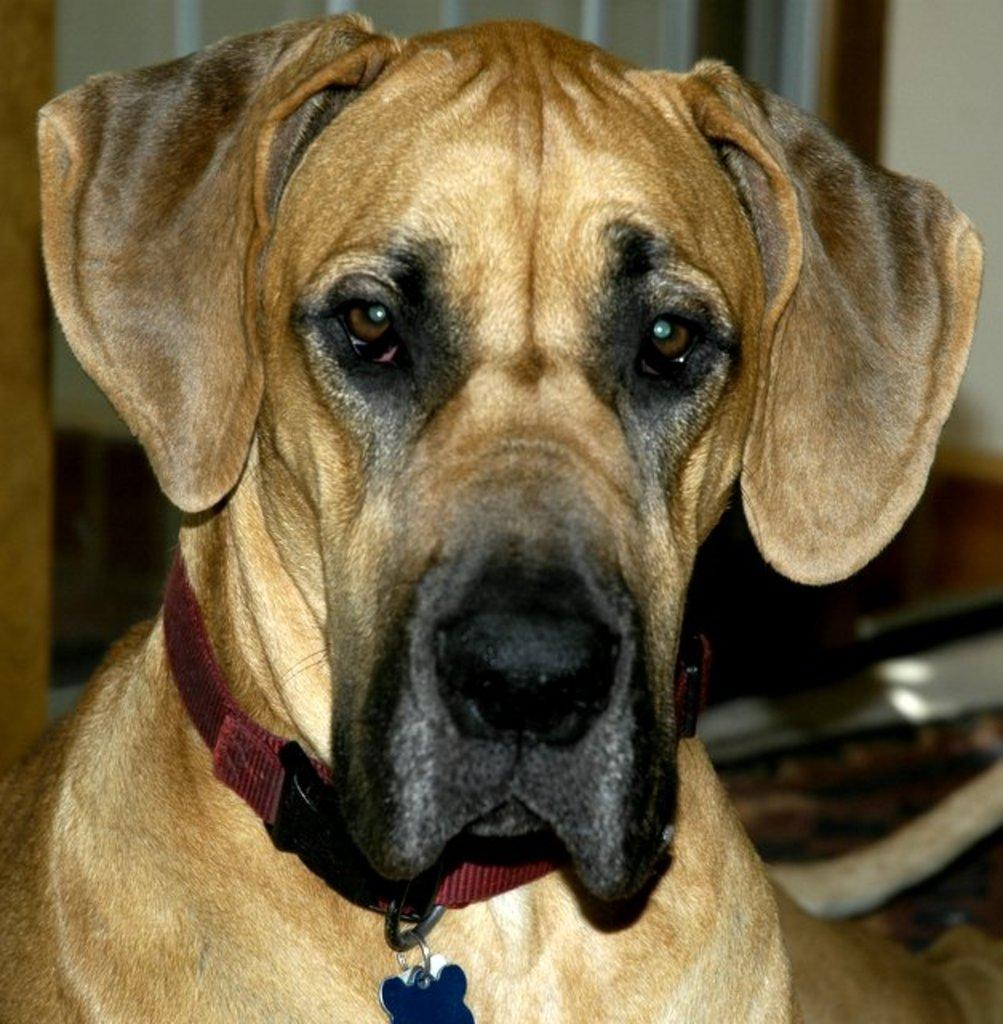What type of animal is in the image? There is a dog in the image. What color is the dog? The dog is brown in color. Is there any indication of the dog's ownership in the image? Yes, the dog has a collar attached to its neck. Is there a rainstorm occurring in the image? No, there is no rainstorm present in the image. What type of metal is visible in the image? There is no metal visible in the image; it features a brown dog with a collar. 